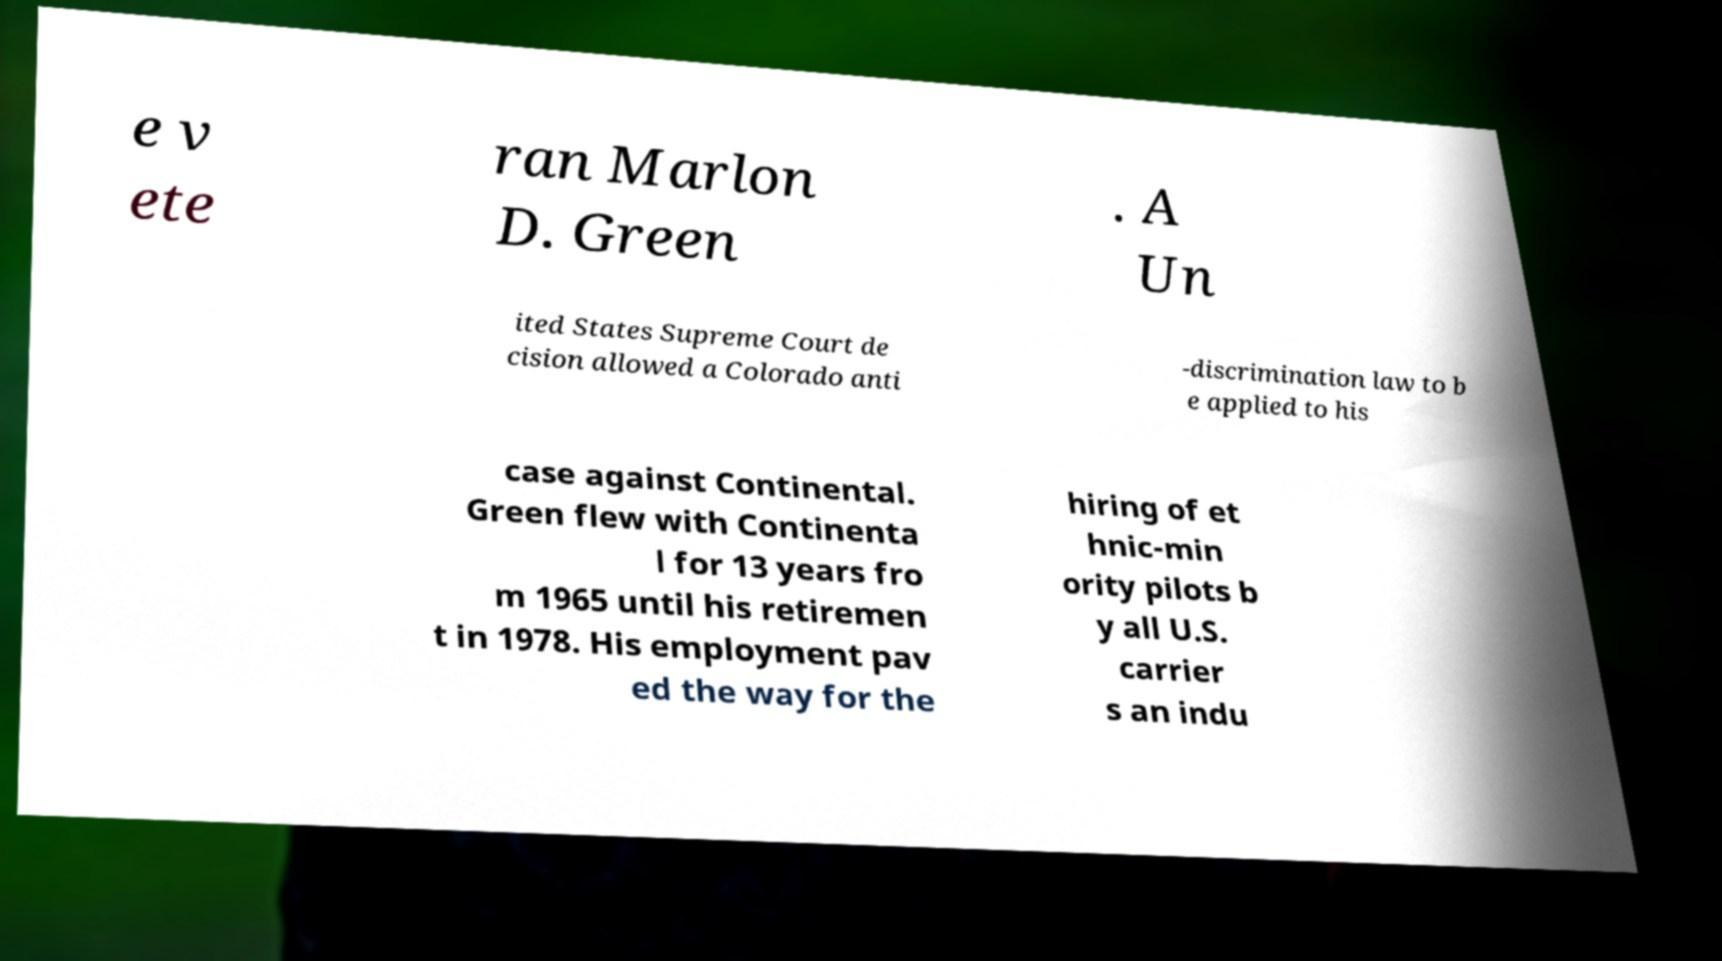Could you assist in decoding the text presented in this image and type it out clearly? e v ete ran Marlon D. Green . A Un ited States Supreme Court de cision allowed a Colorado anti -discrimination law to b e applied to his case against Continental. Green flew with Continenta l for 13 years fro m 1965 until his retiremen t in 1978. His employment pav ed the way for the hiring of et hnic-min ority pilots b y all U.S. carrier s an indu 